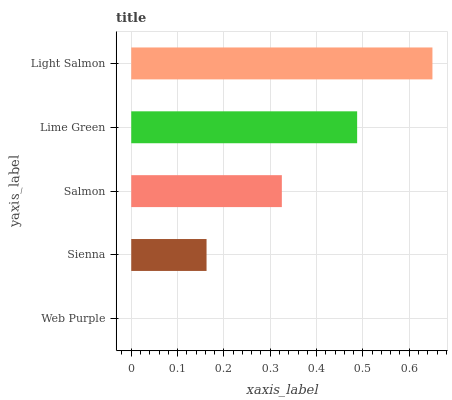Is Web Purple the minimum?
Answer yes or no. Yes. Is Light Salmon the maximum?
Answer yes or no. Yes. Is Sienna the minimum?
Answer yes or no. No. Is Sienna the maximum?
Answer yes or no. No. Is Sienna greater than Web Purple?
Answer yes or no. Yes. Is Web Purple less than Sienna?
Answer yes or no. Yes. Is Web Purple greater than Sienna?
Answer yes or no. No. Is Sienna less than Web Purple?
Answer yes or no. No. Is Salmon the high median?
Answer yes or no. Yes. Is Salmon the low median?
Answer yes or no. Yes. Is Web Purple the high median?
Answer yes or no. No. Is Lime Green the low median?
Answer yes or no. No. 